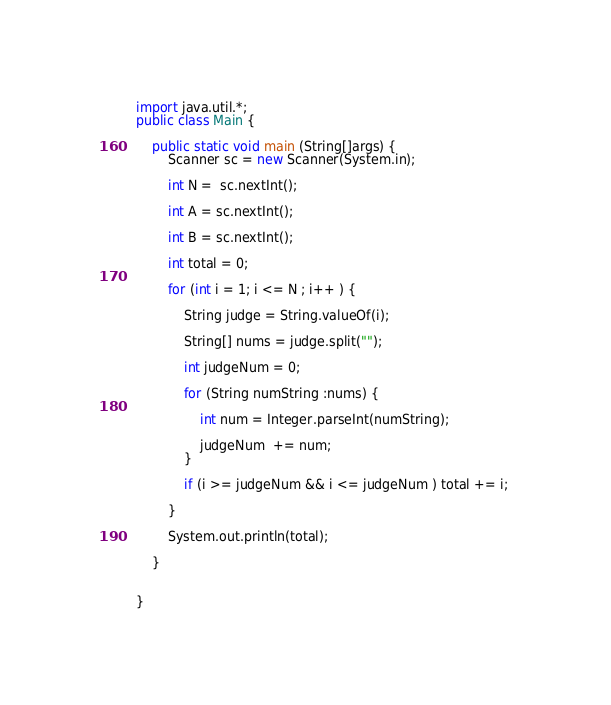<code> <loc_0><loc_0><loc_500><loc_500><_Java_>import java.util.*;
public class Main {
	
	public static void main (String[]args) {
		Scanner sc = new Scanner(System.in);
		
		int N =  sc.nextInt();
		
		int A = sc.nextInt();
		
		int B = sc.nextInt();
		
		int total = 0; 
		
		for (int i = 1; i <= N ; i++ ) {
			
			String judge = String.valueOf(i);
			
			String[] nums = judge.split("");
			
			int judgeNum = 0; 
			
			for (String numString :nums) {
				
				int num = Integer.parseInt(numString);
			
				judgeNum  += num;
			}
			
			if (i >= judgeNum && i <= judgeNum ) total += i; 
			
		}
		
		System.out.println(total);
					
	}	


}</code> 